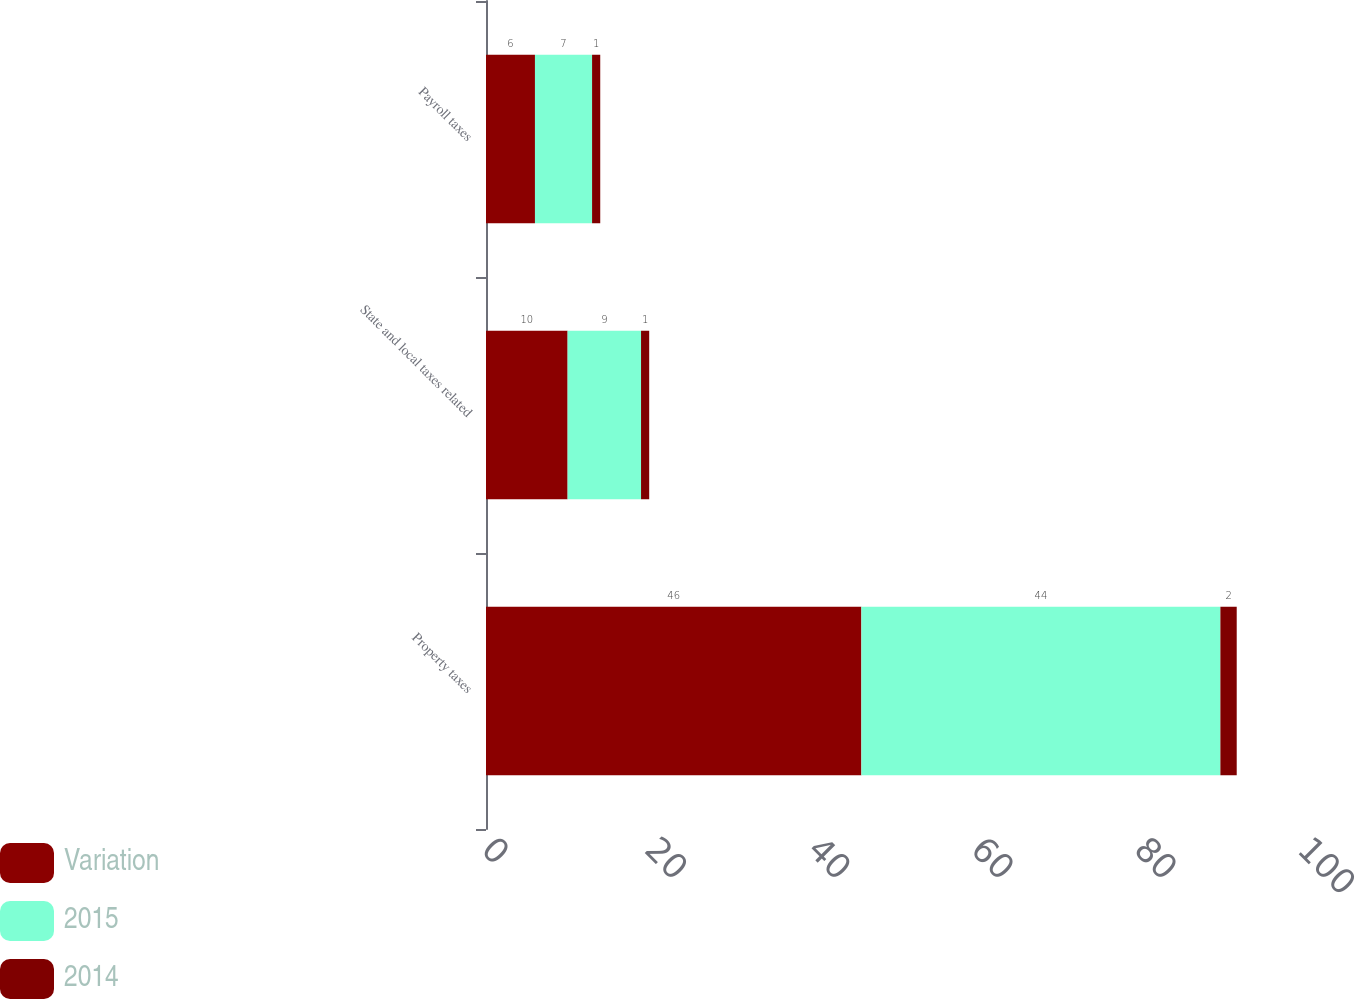Convert chart. <chart><loc_0><loc_0><loc_500><loc_500><stacked_bar_chart><ecel><fcel>Property taxes<fcel>State and local taxes related<fcel>Payroll taxes<nl><fcel>Variation<fcel>46<fcel>10<fcel>6<nl><fcel>2015<fcel>44<fcel>9<fcel>7<nl><fcel>2014<fcel>2<fcel>1<fcel>1<nl></chart> 